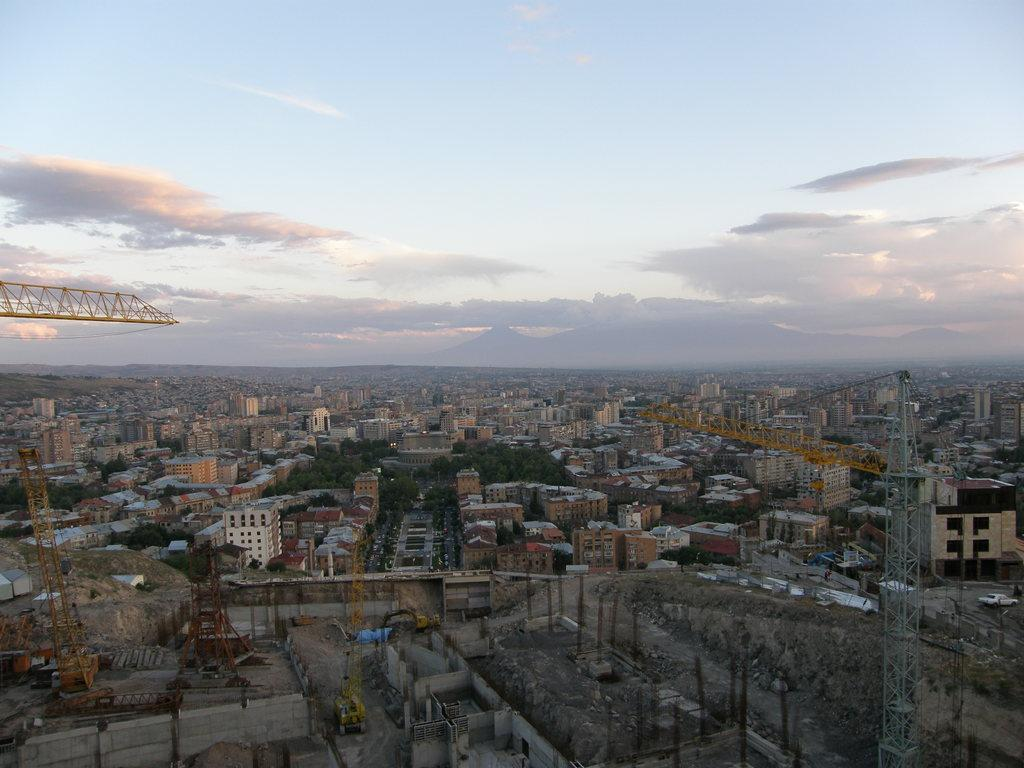What type of structures can be seen in the image? There are many buildings in the image. What construction equipment is present in the image? Tower cranes are present in the image. What type of vegetation is visible in the image? There are trees in the image. What type of vertical structures can be seen in the image? Poles are visible in the image. What is visible in the background of the image? The sky is visible in the background of the image. Where are the oranges being stored in the image? There are no oranges present in the image. What type of material is used to cover the buildings in the image? The buildings in the image do not appear to be covered by any material. 